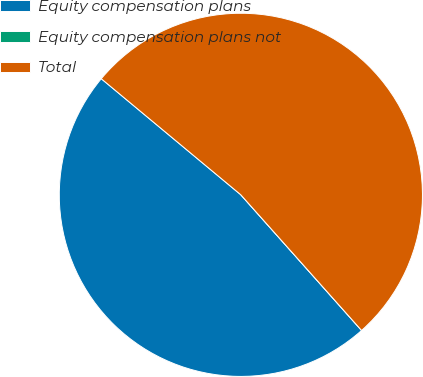<chart> <loc_0><loc_0><loc_500><loc_500><pie_chart><fcel>Equity compensation plans<fcel>Equity compensation plans not<fcel>Total<nl><fcel>47.62%<fcel>0.0%<fcel>52.38%<nl></chart> 